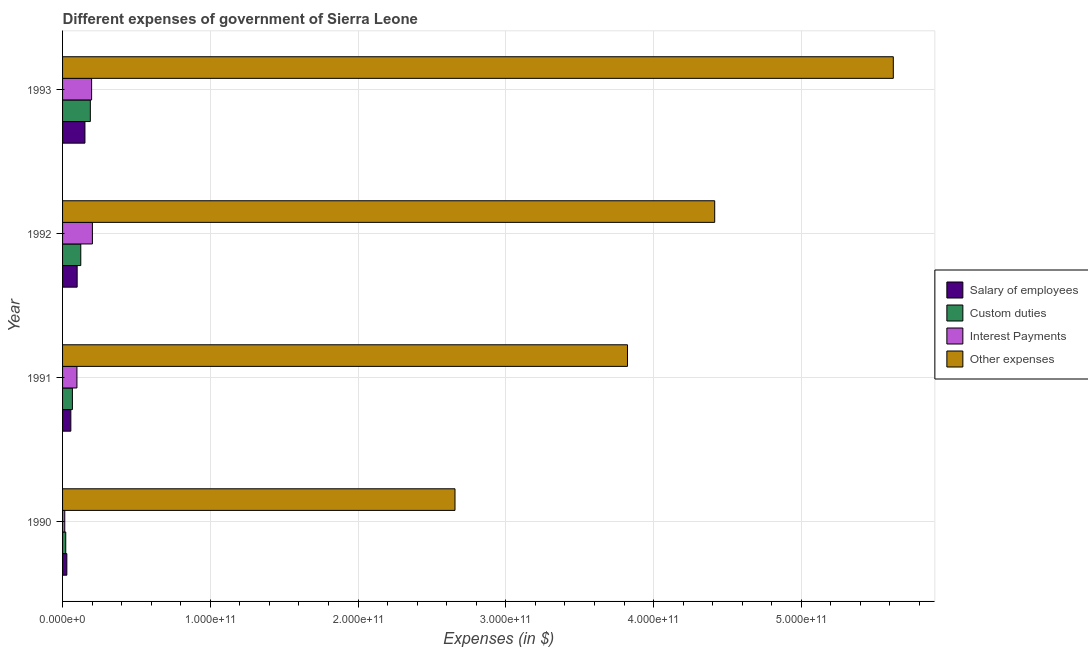How many different coloured bars are there?
Offer a very short reply. 4. How many groups of bars are there?
Keep it short and to the point. 4. Are the number of bars per tick equal to the number of legend labels?
Give a very brief answer. Yes. Are the number of bars on each tick of the Y-axis equal?
Offer a very short reply. Yes. What is the amount spent on custom duties in 1993?
Your answer should be compact. 1.88e+1. Across all years, what is the maximum amount spent on interest payments?
Offer a very short reply. 2.02e+1. Across all years, what is the minimum amount spent on custom duties?
Offer a very short reply. 2.16e+09. In which year was the amount spent on other expenses maximum?
Your answer should be compact. 1993. What is the total amount spent on interest payments in the graph?
Give a very brief answer. 5.11e+1. What is the difference between the amount spent on other expenses in 1992 and that in 1993?
Keep it short and to the point. -1.21e+11. What is the difference between the amount spent on other expenses in 1990 and the amount spent on custom duties in 1992?
Offer a very short reply. 2.53e+11. What is the average amount spent on salary of employees per year?
Ensure brevity in your answer.  8.38e+09. In the year 1992, what is the difference between the amount spent on other expenses and amount spent on salary of employees?
Ensure brevity in your answer.  4.32e+11. What is the ratio of the amount spent on interest payments in 1991 to that in 1993?
Offer a terse response. 0.49. What is the difference between the highest and the second highest amount spent on other expenses?
Ensure brevity in your answer.  1.21e+11. What is the difference between the highest and the lowest amount spent on salary of employees?
Offer a terse response. 1.23e+1. Is the sum of the amount spent on interest payments in 1990 and 1992 greater than the maximum amount spent on other expenses across all years?
Provide a short and direct response. No. What does the 2nd bar from the top in 1991 represents?
Your response must be concise. Interest Payments. What does the 3rd bar from the bottom in 1993 represents?
Ensure brevity in your answer.  Interest Payments. Is it the case that in every year, the sum of the amount spent on salary of employees and amount spent on custom duties is greater than the amount spent on interest payments?
Provide a succinct answer. Yes. Are all the bars in the graph horizontal?
Provide a short and direct response. Yes. What is the difference between two consecutive major ticks on the X-axis?
Offer a terse response. 1.00e+11. Are the values on the major ticks of X-axis written in scientific E-notation?
Provide a succinct answer. Yes. Does the graph contain any zero values?
Your response must be concise. No. How many legend labels are there?
Ensure brevity in your answer.  4. How are the legend labels stacked?
Your response must be concise. Vertical. What is the title of the graph?
Offer a very short reply. Different expenses of government of Sierra Leone. Does "Pre-primary schools" appear as one of the legend labels in the graph?
Your answer should be compact. No. What is the label or title of the X-axis?
Make the answer very short. Expenses (in $). What is the label or title of the Y-axis?
Ensure brevity in your answer.  Year. What is the Expenses (in $) of Salary of employees in 1990?
Your answer should be very brief. 2.89e+09. What is the Expenses (in $) of Custom duties in 1990?
Provide a short and direct response. 2.16e+09. What is the Expenses (in $) in Interest Payments in 1990?
Your answer should be compact. 1.49e+09. What is the Expenses (in $) of Other expenses in 1990?
Your response must be concise. 2.66e+11. What is the Expenses (in $) in Salary of employees in 1991?
Keep it short and to the point. 5.60e+09. What is the Expenses (in $) of Custom duties in 1991?
Ensure brevity in your answer.  6.66e+09. What is the Expenses (in $) of Interest Payments in 1991?
Offer a very short reply. 9.73e+09. What is the Expenses (in $) in Other expenses in 1991?
Keep it short and to the point. 3.82e+11. What is the Expenses (in $) of Salary of employees in 1992?
Your answer should be compact. 9.88e+09. What is the Expenses (in $) in Custom duties in 1992?
Make the answer very short. 1.23e+1. What is the Expenses (in $) of Interest Payments in 1992?
Your answer should be very brief. 2.02e+1. What is the Expenses (in $) in Other expenses in 1992?
Provide a short and direct response. 4.41e+11. What is the Expenses (in $) in Salary of employees in 1993?
Keep it short and to the point. 1.51e+1. What is the Expenses (in $) of Custom duties in 1993?
Offer a terse response. 1.88e+1. What is the Expenses (in $) of Interest Payments in 1993?
Your answer should be very brief. 1.97e+1. What is the Expenses (in $) in Other expenses in 1993?
Ensure brevity in your answer.  5.62e+11. Across all years, what is the maximum Expenses (in $) of Salary of employees?
Your answer should be very brief. 1.51e+1. Across all years, what is the maximum Expenses (in $) of Custom duties?
Provide a succinct answer. 1.88e+1. Across all years, what is the maximum Expenses (in $) in Interest Payments?
Ensure brevity in your answer.  2.02e+1. Across all years, what is the maximum Expenses (in $) in Other expenses?
Provide a succinct answer. 5.62e+11. Across all years, what is the minimum Expenses (in $) in Salary of employees?
Your response must be concise. 2.89e+09. Across all years, what is the minimum Expenses (in $) of Custom duties?
Your answer should be compact. 2.16e+09. Across all years, what is the minimum Expenses (in $) in Interest Payments?
Your response must be concise. 1.49e+09. Across all years, what is the minimum Expenses (in $) of Other expenses?
Provide a succinct answer. 2.66e+11. What is the total Expenses (in $) of Salary of employees in the graph?
Ensure brevity in your answer.  3.35e+1. What is the total Expenses (in $) in Custom duties in the graph?
Offer a very short reply. 3.99e+1. What is the total Expenses (in $) in Interest Payments in the graph?
Ensure brevity in your answer.  5.11e+1. What is the total Expenses (in $) of Other expenses in the graph?
Keep it short and to the point. 1.65e+12. What is the difference between the Expenses (in $) of Salary of employees in 1990 and that in 1991?
Give a very brief answer. -2.71e+09. What is the difference between the Expenses (in $) in Custom duties in 1990 and that in 1991?
Your response must be concise. -4.50e+09. What is the difference between the Expenses (in $) in Interest Payments in 1990 and that in 1991?
Your answer should be compact. -8.24e+09. What is the difference between the Expenses (in $) in Other expenses in 1990 and that in 1991?
Ensure brevity in your answer.  -1.17e+11. What is the difference between the Expenses (in $) in Salary of employees in 1990 and that in 1992?
Offer a very short reply. -6.98e+09. What is the difference between the Expenses (in $) in Custom duties in 1990 and that in 1992?
Your response must be concise. -1.02e+1. What is the difference between the Expenses (in $) in Interest Payments in 1990 and that in 1992?
Make the answer very short. -1.87e+1. What is the difference between the Expenses (in $) in Other expenses in 1990 and that in 1992?
Your answer should be compact. -1.76e+11. What is the difference between the Expenses (in $) of Salary of employees in 1990 and that in 1993?
Make the answer very short. -1.23e+1. What is the difference between the Expenses (in $) of Custom duties in 1990 and that in 1993?
Provide a short and direct response. -1.66e+1. What is the difference between the Expenses (in $) of Interest Payments in 1990 and that in 1993?
Offer a very short reply. -1.82e+1. What is the difference between the Expenses (in $) of Other expenses in 1990 and that in 1993?
Make the answer very short. -2.97e+11. What is the difference between the Expenses (in $) in Salary of employees in 1991 and that in 1992?
Your answer should be compact. -4.28e+09. What is the difference between the Expenses (in $) in Custom duties in 1991 and that in 1992?
Your answer should be compact. -5.68e+09. What is the difference between the Expenses (in $) in Interest Payments in 1991 and that in 1992?
Offer a terse response. -1.05e+1. What is the difference between the Expenses (in $) in Other expenses in 1991 and that in 1992?
Give a very brief answer. -5.90e+1. What is the difference between the Expenses (in $) in Salary of employees in 1991 and that in 1993?
Make the answer very short. -9.55e+09. What is the difference between the Expenses (in $) of Custom duties in 1991 and that in 1993?
Provide a succinct answer. -1.21e+1. What is the difference between the Expenses (in $) in Interest Payments in 1991 and that in 1993?
Keep it short and to the point. -9.93e+09. What is the difference between the Expenses (in $) in Other expenses in 1991 and that in 1993?
Provide a succinct answer. -1.80e+11. What is the difference between the Expenses (in $) in Salary of employees in 1992 and that in 1993?
Give a very brief answer. -5.27e+09. What is the difference between the Expenses (in $) of Custom duties in 1992 and that in 1993?
Give a very brief answer. -6.46e+09. What is the difference between the Expenses (in $) in Interest Payments in 1992 and that in 1993?
Keep it short and to the point. 5.41e+08. What is the difference between the Expenses (in $) in Other expenses in 1992 and that in 1993?
Provide a succinct answer. -1.21e+11. What is the difference between the Expenses (in $) in Salary of employees in 1990 and the Expenses (in $) in Custom duties in 1991?
Make the answer very short. -3.77e+09. What is the difference between the Expenses (in $) in Salary of employees in 1990 and the Expenses (in $) in Interest Payments in 1991?
Make the answer very short. -6.84e+09. What is the difference between the Expenses (in $) of Salary of employees in 1990 and the Expenses (in $) of Other expenses in 1991?
Give a very brief answer. -3.79e+11. What is the difference between the Expenses (in $) in Custom duties in 1990 and the Expenses (in $) in Interest Payments in 1991?
Offer a terse response. -7.57e+09. What is the difference between the Expenses (in $) of Custom duties in 1990 and the Expenses (in $) of Other expenses in 1991?
Ensure brevity in your answer.  -3.80e+11. What is the difference between the Expenses (in $) in Interest Payments in 1990 and the Expenses (in $) in Other expenses in 1991?
Your response must be concise. -3.81e+11. What is the difference between the Expenses (in $) in Salary of employees in 1990 and the Expenses (in $) in Custom duties in 1992?
Ensure brevity in your answer.  -9.44e+09. What is the difference between the Expenses (in $) in Salary of employees in 1990 and the Expenses (in $) in Interest Payments in 1992?
Offer a terse response. -1.73e+1. What is the difference between the Expenses (in $) in Salary of employees in 1990 and the Expenses (in $) in Other expenses in 1992?
Provide a short and direct response. -4.38e+11. What is the difference between the Expenses (in $) of Custom duties in 1990 and the Expenses (in $) of Interest Payments in 1992?
Make the answer very short. -1.80e+1. What is the difference between the Expenses (in $) in Custom duties in 1990 and the Expenses (in $) in Other expenses in 1992?
Make the answer very short. -4.39e+11. What is the difference between the Expenses (in $) of Interest Payments in 1990 and the Expenses (in $) of Other expenses in 1992?
Offer a terse response. -4.40e+11. What is the difference between the Expenses (in $) in Salary of employees in 1990 and the Expenses (in $) in Custom duties in 1993?
Offer a terse response. -1.59e+1. What is the difference between the Expenses (in $) of Salary of employees in 1990 and the Expenses (in $) of Interest Payments in 1993?
Make the answer very short. -1.68e+1. What is the difference between the Expenses (in $) of Salary of employees in 1990 and the Expenses (in $) of Other expenses in 1993?
Provide a succinct answer. -5.59e+11. What is the difference between the Expenses (in $) in Custom duties in 1990 and the Expenses (in $) in Interest Payments in 1993?
Provide a succinct answer. -1.75e+1. What is the difference between the Expenses (in $) in Custom duties in 1990 and the Expenses (in $) in Other expenses in 1993?
Provide a short and direct response. -5.60e+11. What is the difference between the Expenses (in $) in Interest Payments in 1990 and the Expenses (in $) in Other expenses in 1993?
Give a very brief answer. -5.61e+11. What is the difference between the Expenses (in $) in Salary of employees in 1991 and the Expenses (in $) in Custom duties in 1992?
Keep it short and to the point. -6.73e+09. What is the difference between the Expenses (in $) in Salary of employees in 1991 and the Expenses (in $) in Interest Payments in 1992?
Give a very brief answer. -1.46e+1. What is the difference between the Expenses (in $) of Salary of employees in 1991 and the Expenses (in $) of Other expenses in 1992?
Offer a terse response. -4.36e+11. What is the difference between the Expenses (in $) of Custom duties in 1991 and the Expenses (in $) of Interest Payments in 1992?
Keep it short and to the point. -1.35e+1. What is the difference between the Expenses (in $) of Custom duties in 1991 and the Expenses (in $) of Other expenses in 1992?
Provide a succinct answer. -4.35e+11. What is the difference between the Expenses (in $) in Interest Payments in 1991 and the Expenses (in $) in Other expenses in 1992?
Offer a terse response. -4.32e+11. What is the difference between the Expenses (in $) in Salary of employees in 1991 and the Expenses (in $) in Custom duties in 1993?
Your answer should be very brief. -1.32e+1. What is the difference between the Expenses (in $) of Salary of employees in 1991 and the Expenses (in $) of Interest Payments in 1993?
Offer a terse response. -1.41e+1. What is the difference between the Expenses (in $) of Salary of employees in 1991 and the Expenses (in $) of Other expenses in 1993?
Your answer should be very brief. -5.57e+11. What is the difference between the Expenses (in $) of Custom duties in 1991 and the Expenses (in $) of Interest Payments in 1993?
Your answer should be compact. -1.30e+1. What is the difference between the Expenses (in $) in Custom duties in 1991 and the Expenses (in $) in Other expenses in 1993?
Your answer should be very brief. -5.56e+11. What is the difference between the Expenses (in $) in Interest Payments in 1991 and the Expenses (in $) in Other expenses in 1993?
Provide a short and direct response. -5.53e+11. What is the difference between the Expenses (in $) of Salary of employees in 1992 and the Expenses (in $) of Custom duties in 1993?
Keep it short and to the point. -8.92e+09. What is the difference between the Expenses (in $) in Salary of employees in 1992 and the Expenses (in $) in Interest Payments in 1993?
Offer a very short reply. -9.78e+09. What is the difference between the Expenses (in $) in Salary of employees in 1992 and the Expenses (in $) in Other expenses in 1993?
Your answer should be very brief. -5.52e+11. What is the difference between the Expenses (in $) of Custom duties in 1992 and the Expenses (in $) of Interest Payments in 1993?
Provide a short and direct response. -7.32e+09. What is the difference between the Expenses (in $) in Custom duties in 1992 and the Expenses (in $) in Other expenses in 1993?
Ensure brevity in your answer.  -5.50e+11. What is the difference between the Expenses (in $) of Interest Payments in 1992 and the Expenses (in $) of Other expenses in 1993?
Keep it short and to the point. -5.42e+11. What is the average Expenses (in $) in Salary of employees per year?
Your answer should be very brief. 8.38e+09. What is the average Expenses (in $) of Custom duties per year?
Offer a terse response. 9.99e+09. What is the average Expenses (in $) in Interest Payments per year?
Make the answer very short. 1.28e+1. What is the average Expenses (in $) of Other expenses per year?
Keep it short and to the point. 4.13e+11. In the year 1990, what is the difference between the Expenses (in $) of Salary of employees and Expenses (in $) of Custom duties?
Your answer should be very brief. 7.31e+08. In the year 1990, what is the difference between the Expenses (in $) in Salary of employees and Expenses (in $) in Interest Payments?
Offer a terse response. 1.40e+09. In the year 1990, what is the difference between the Expenses (in $) of Salary of employees and Expenses (in $) of Other expenses?
Provide a short and direct response. -2.63e+11. In the year 1990, what is the difference between the Expenses (in $) of Custom duties and Expenses (in $) of Interest Payments?
Your answer should be very brief. 6.70e+08. In the year 1990, what is the difference between the Expenses (in $) of Custom duties and Expenses (in $) of Other expenses?
Give a very brief answer. -2.63e+11. In the year 1990, what is the difference between the Expenses (in $) in Interest Payments and Expenses (in $) in Other expenses?
Offer a very short reply. -2.64e+11. In the year 1991, what is the difference between the Expenses (in $) of Salary of employees and Expenses (in $) of Custom duties?
Offer a very short reply. -1.06e+09. In the year 1991, what is the difference between the Expenses (in $) of Salary of employees and Expenses (in $) of Interest Payments?
Make the answer very short. -4.13e+09. In the year 1991, what is the difference between the Expenses (in $) in Salary of employees and Expenses (in $) in Other expenses?
Your answer should be compact. -3.77e+11. In the year 1991, what is the difference between the Expenses (in $) in Custom duties and Expenses (in $) in Interest Payments?
Offer a very short reply. -3.07e+09. In the year 1991, what is the difference between the Expenses (in $) of Custom duties and Expenses (in $) of Other expenses?
Your answer should be compact. -3.76e+11. In the year 1991, what is the difference between the Expenses (in $) of Interest Payments and Expenses (in $) of Other expenses?
Offer a terse response. -3.73e+11. In the year 1992, what is the difference between the Expenses (in $) in Salary of employees and Expenses (in $) in Custom duties?
Offer a terse response. -2.46e+09. In the year 1992, what is the difference between the Expenses (in $) of Salary of employees and Expenses (in $) of Interest Payments?
Keep it short and to the point. -1.03e+1. In the year 1992, what is the difference between the Expenses (in $) of Salary of employees and Expenses (in $) of Other expenses?
Give a very brief answer. -4.32e+11. In the year 1992, what is the difference between the Expenses (in $) of Custom duties and Expenses (in $) of Interest Payments?
Your response must be concise. -7.86e+09. In the year 1992, what is the difference between the Expenses (in $) in Custom duties and Expenses (in $) in Other expenses?
Ensure brevity in your answer.  -4.29e+11. In the year 1992, what is the difference between the Expenses (in $) in Interest Payments and Expenses (in $) in Other expenses?
Your answer should be compact. -4.21e+11. In the year 1993, what is the difference between the Expenses (in $) in Salary of employees and Expenses (in $) in Custom duties?
Offer a terse response. -3.65e+09. In the year 1993, what is the difference between the Expenses (in $) in Salary of employees and Expenses (in $) in Interest Payments?
Make the answer very short. -4.51e+09. In the year 1993, what is the difference between the Expenses (in $) of Salary of employees and Expenses (in $) of Other expenses?
Give a very brief answer. -5.47e+11. In the year 1993, what is the difference between the Expenses (in $) of Custom duties and Expenses (in $) of Interest Payments?
Offer a very short reply. -8.60e+08. In the year 1993, what is the difference between the Expenses (in $) in Custom duties and Expenses (in $) in Other expenses?
Ensure brevity in your answer.  -5.43e+11. In the year 1993, what is the difference between the Expenses (in $) in Interest Payments and Expenses (in $) in Other expenses?
Give a very brief answer. -5.43e+11. What is the ratio of the Expenses (in $) in Salary of employees in 1990 to that in 1991?
Make the answer very short. 0.52. What is the ratio of the Expenses (in $) of Custom duties in 1990 to that in 1991?
Provide a short and direct response. 0.32. What is the ratio of the Expenses (in $) of Interest Payments in 1990 to that in 1991?
Your answer should be compact. 0.15. What is the ratio of the Expenses (in $) of Other expenses in 1990 to that in 1991?
Your response must be concise. 0.69. What is the ratio of the Expenses (in $) of Salary of employees in 1990 to that in 1992?
Keep it short and to the point. 0.29. What is the ratio of the Expenses (in $) in Custom duties in 1990 to that in 1992?
Offer a terse response. 0.18. What is the ratio of the Expenses (in $) of Interest Payments in 1990 to that in 1992?
Give a very brief answer. 0.07. What is the ratio of the Expenses (in $) in Other expenses in 1990 to that in 1992?
Make the answer very short. 0.6. What is the ratio of the Expenses (in $) of Salary of employees in 1990 to that in 1993?
Offer a very short reply. 0.19. What is the ratio of the Expenses (in $) in Custom duties in 1990 to that in 1993?
Provide a short and direct response. 0.11. What is the ratio of the Expenses (in $) of Interest Payments in 1990 to that in 1993?
Provide a succinct answer. 0.08. What is the ratio of the Expenses (in $) in Other expenses in 1990 to that in 1993?
Ensure brevity in your answer.  0.47. What is the ratio of the Expenses (in $) of Salary of employees in 1991 to that in 1992?
Your answer should be compact. 0.57. What is the ratio of the Expenses (in $) in Custom duties in 1991 to that in 1992?
Offer a very short reply. 0.54. What is the ratio of the Expenses (in $) of Interest Payments in 1991 to that in 1992?
Offer a very short reply. 0.48. What is the ratio of the Expenses (in $) of Other expenses in 1991 to that in 1992?
Your response must be concise. 0.87. What is the ratio of the Expenses (in $) in Salary of employees in 1991 to that in 1993?
Keep it short and to the point. 0.37. What is the ratio of the Expenses (in $) in Custom duties in 1991 to that in 1993?
Provide a succinct answer. 0.35. What is the ratio of the Expenses (in $) of Interest Payments in 1991 to that in 1993?
Offer a terse response. 0.49. What is the ratio of the Expenses (in $) of Other expenses in 1991 to that in 1993?
Your answer should be compact. 0.68. What is the ratio of the Expenses (in $) in Salary of employees in 1992 to that in 1993?
Your response must be concise. 0.65. What is the ratio of the Expenses (in $) of Custom duties in 1992 to that in 1993?
Give a very brief answer. 0.66. What is the ratio of the Expenses (in $) of Interest Payments in 1992 to that in 1993?
Your answer should be compact. 1.03. What is the ratio of the Expenses (in $) in Other expenses in 1992 to that in 1993?
Make the answer very short. 0.79. What is the difference between the highest and the second highest Expenses (in $) in Salary of employees?
Offer a very short reply. 5.27e+09. What is the difference between the highest and the second highest Expenses (in $) in Custom duties?
Give a very brief answer. 6.46e+09. What is the difference between the highest and the second highest Expenses (in $) in Interest Payments?
Provide a short and direct response. 5.41e+08. What is the difference between the highest and the second highest Expenses (in $) in Other expenses?
Provide a succinct answer. 1.21e+11. What is the difference between the highest and the lowest Expenses (in $) in Salary of employees?
Make the answer very short. 1.23e+1. What is the difference between the highest and the lowest Expenses (in $) in Custom duties?
Your answer should be very brief. 1.66e+1. What is the difference between the highest and the lowest Expenses (in $) in Interest Payments?
Your answer should be very brief. 1.87e+1. What is the difference between the highest and the lowest Expenses (in $) of Other expenses?
Offer a very short reply. 2.97e+11. 